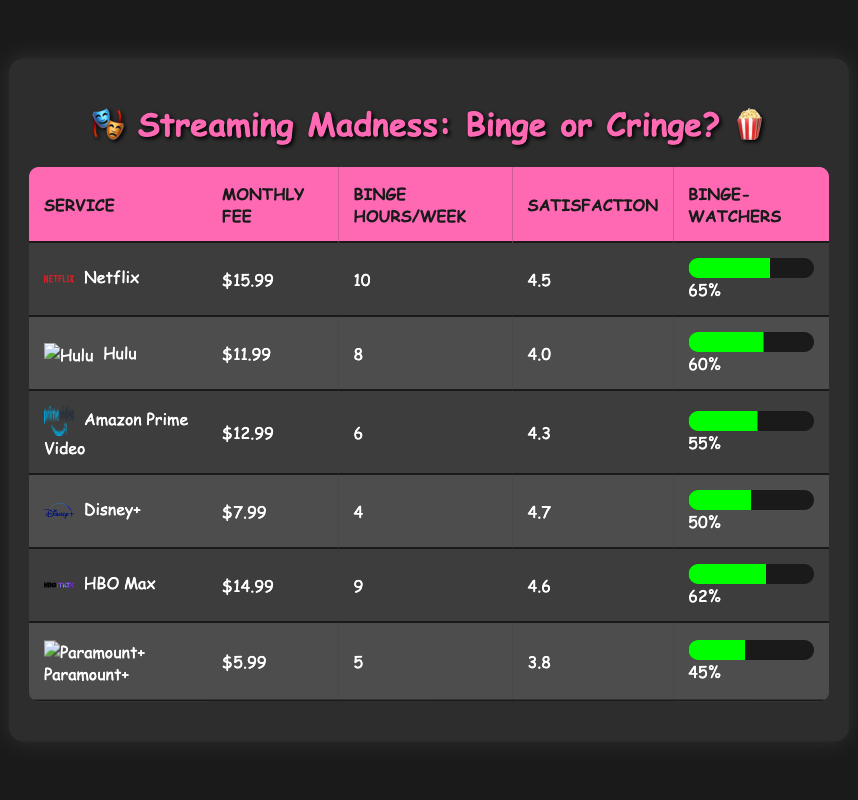What is the monthly subscription fee for Hulu? Referring to the table, the monthly subscription fee listed for Hulu is $11.99.
Answer: $11.99 Which streaming service has the highest user satisfaction rating? By comparing the user satisfaction ratings, Netflix has a rating of 4.5, Hulu is 4.0, Amazon Prime Video is 4.3, Disney+ is 4.7, HBO Max is 4.6, and Paramount+ is 3.8. The highest is Disney+ at 4.7.
Answer: Disney+ What is the average number of binge-watching hours per week across all services? To calculate the average, sum the binge-watching hours: (10 + 8 + 6 + 4 + 9 + 5) = 42 hours. There are 6 services, so the average is 42/6 = 7.
Answer: 7 Is the percentage of viewers who binge-watch for Amazon Prime Video greater than that of Disney+? From the table, Amazon Prime Video has 55% of viewers who binge-watch, while Disney+ has 50%. This shows that Amazon Prime Video has a higher percentage.
Answer: Yes What is the difference in average binge-watch hours per week between Netflix and Paramount+? Netflix has 10 hours and Paramount+ has 5 hours for binge-watching. The difference is 10 - 5 = 5 hours.
Answer: 5 Is the user satisfaction rating of HBO Max higher than that of Paramount+? HBO Max has a user satisfaction rating of 4.6 while Paramount+ has a rating of 3.8. Since 4.6 is greater than 3.8, HBO Max has a higher rating.
Answer: Yes What is the average monthly subscription fee of the streaming services listed? Sum the monthly subscription fees: (15.99 + 11.99 + 12.99 + 7.99 + 14.99 + 5.99) = 69.94. There are 6 services, thus the average is 69.94/6 = 11.66.
Answer: 11.66 Which service has the lowest percentage of viewers who binge-watch? Checking the percentages, Paramount+ has 45% of viewers who binge-watch, which is the lowest compared to other services.
Answer: Paramount+ Is there a direct correlation between subscription fees and average binge-watch hours? The table shows no clear numerical trend confirming this correlation. For example, higher fees do not consistently result in more binge-watching hours (Netflix is highest at 10 hours, but also has the highest fee).
Answer: No 